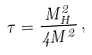<formula> <loc_0><loc_0><loc_500><loc_500>\tau = \frac { M _ { H } ^ { 2 } } { 4 M ^ { 2 } } \, ,</formula> 